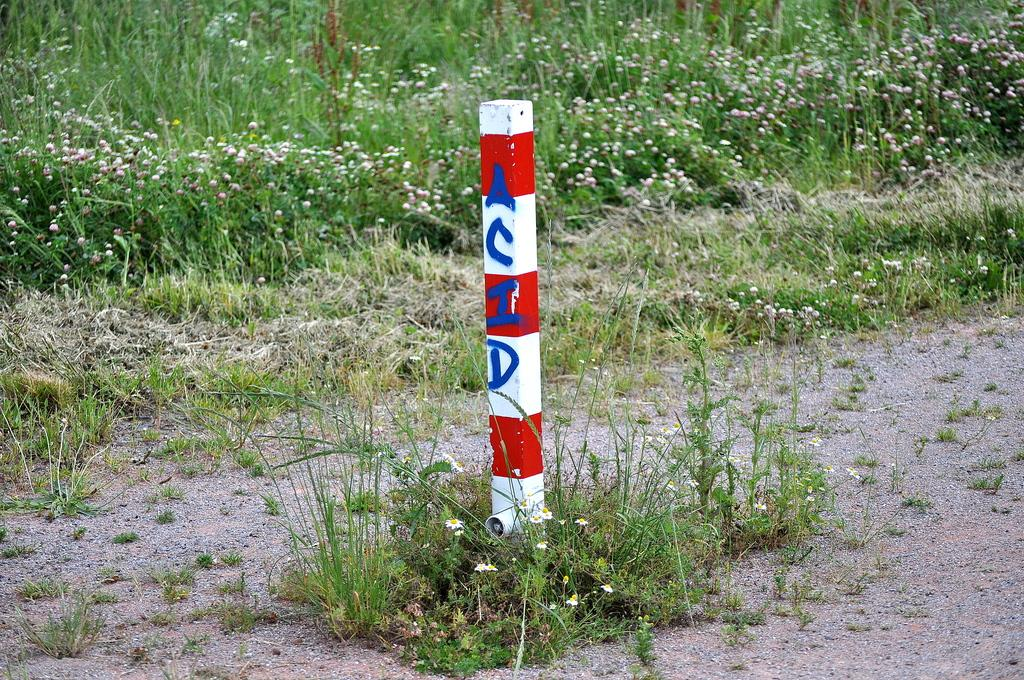What is the main subject in the center of the image? There is a pole with text in the center of the image. What can be seen in the background of the image? There are plants in the background of the image. What type of apparel is being worn by the cattle in the image? There are no cattle present in the image, so it is not possible to determine what type of apparel they might be wearing. 